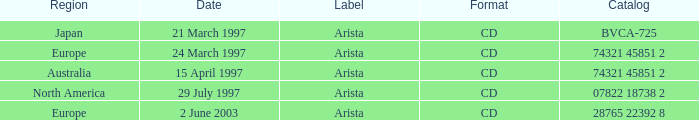Can you give me this table as a dict? {'header': ['Region', 'Date', 'Label', 'Format', 'Catalog'], 'rows': [['Japan', '21 March 1997', 'Arista', 'CD', 'BVCA-725'], ['Europe', '24 March 1997', 'Arista', 'CD', '74321 45851 2'], ['Australia', '15 April 1997', 'Arista', 'CD', '74321 45851 2'], ['North America', '29 July 1997', 'Arista', 'CD', '07822 18738 2'], ['Europe', '2 June 2003', 'Arista', 'CD', '28765 22392 8']]} What Date has the Region Europe and a Catalog of 74321 45851 2? 24 March 1997. 